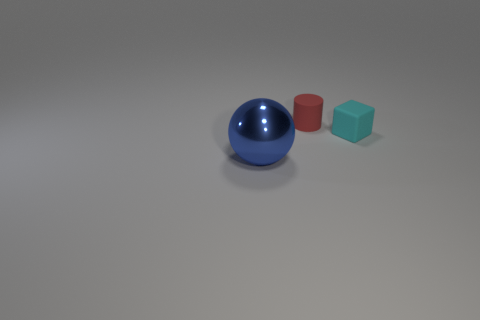Add 1 small matte cylinders. How many objects exist? 4 Subtract all cylinders. How many objects are left? 2 Add 1 large cyan cubes. How many large cyan cubes exist? 1 Subtract 1 red cylinders. How many objects are left? 2 Subtract all large cylinders. Subtract all small cyan things. How many objects are left? 2 Add 3 spheres. How many spheres are left? 4 